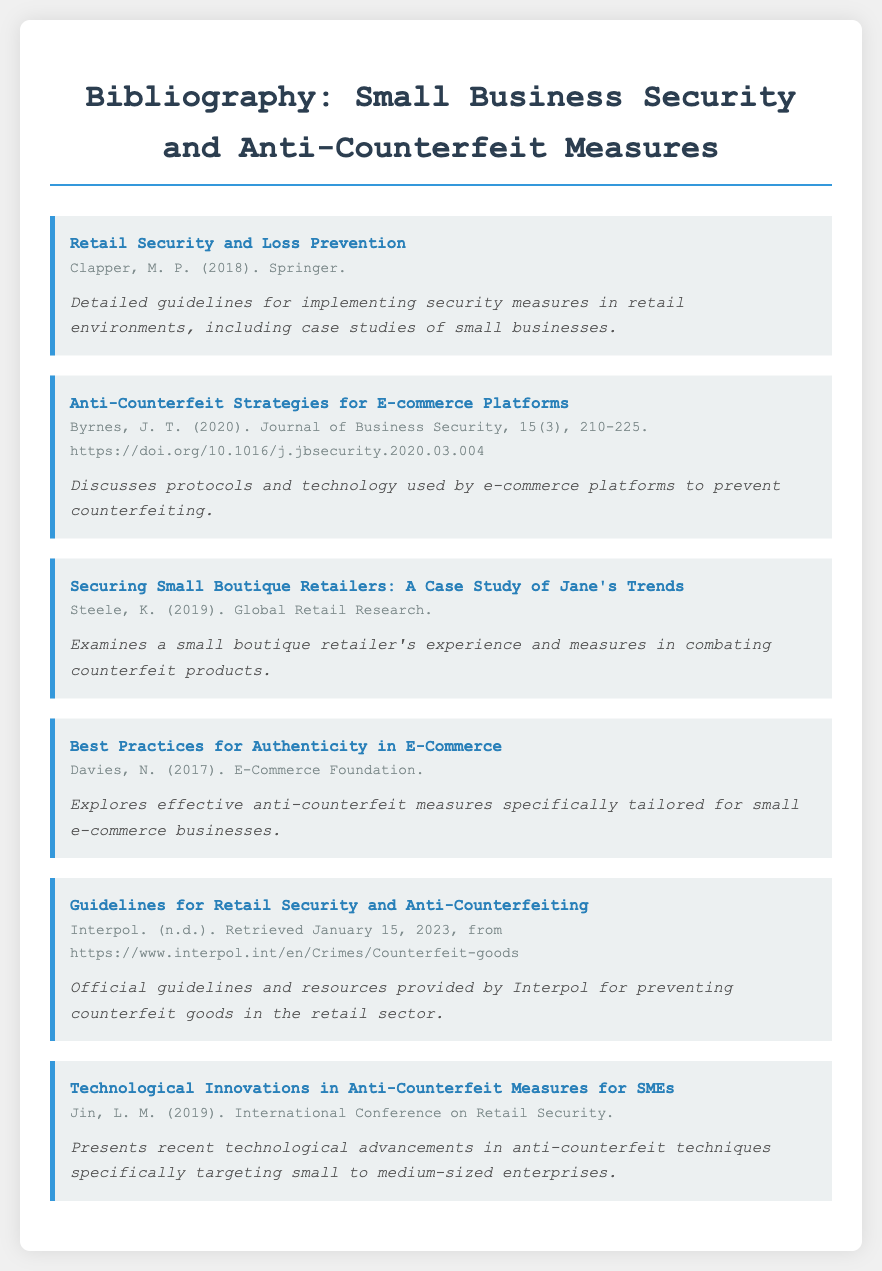what is the title of the first entry? The title of the first entry is "Retail Security and Loss Prevention."
Answer: Retail Security and Loss Prevention who is the author of the second entry? The author of the second entry is J. T. Byrnes.
Answer: J. T. Byrnes what year was the entry about "Securing Small Boutique Retailers" published? The entry was published in 2019.
Answer: 2019 how many entries are cited in the bibliography? There are a total of six entries cited in the bibliography.
Answer: six what type of document contains these entries? The document type is a bibliography.
Answer: bibliography which organization provides guidelines for retail security according to the document? The organization is Interpol.
Answer: Interpol what is the focus of the entry by Jin, L. M.? The focus is on technological innovations in anti-counterfeit measures for SMEs.
Answer: technological innovations in anti-counterfeit measures for SMEs what year was the entry "Best Practices for Authenticity in E-Commerce" published? The entry was published in 2017.
Answer: 2017 